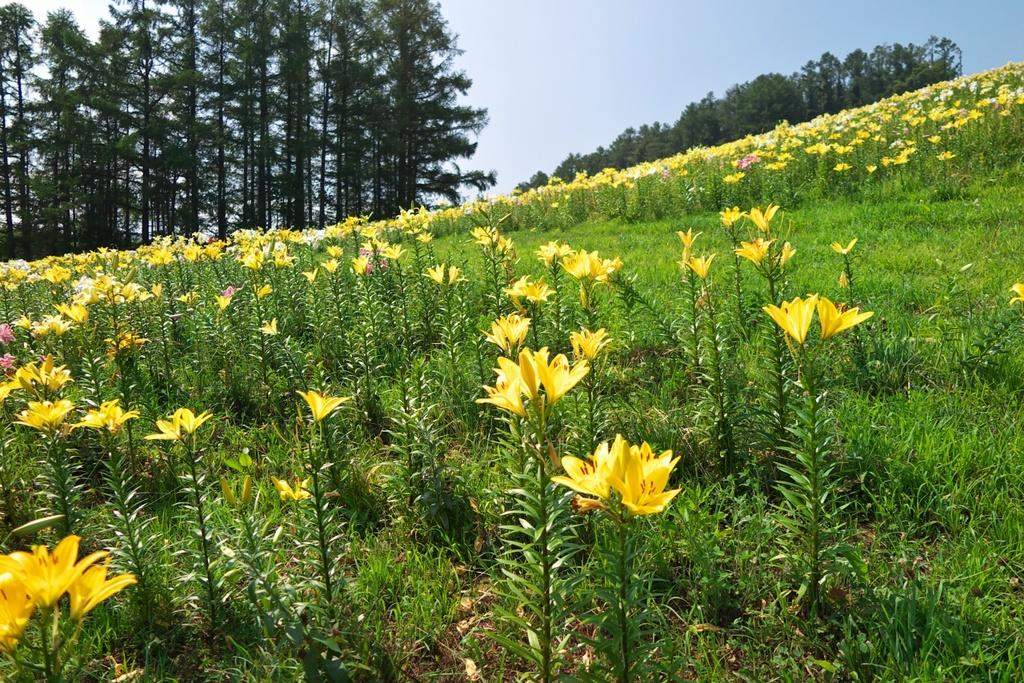What type of living organisms can be seen in the image? Plants and trees are visible in the image. What color are the flowers in the image? There are yellow flowers in the image. What can be seen in the sky in the image? The sky is visible in the image. What type of oil can be seen dripping from the trees in the image? There is no oil present in the image; it features plants and trees with yellow flowers. Where is the party taking place in the image? There is no party depicted in the image; it only shows plants, trees, and yellow flowers. 